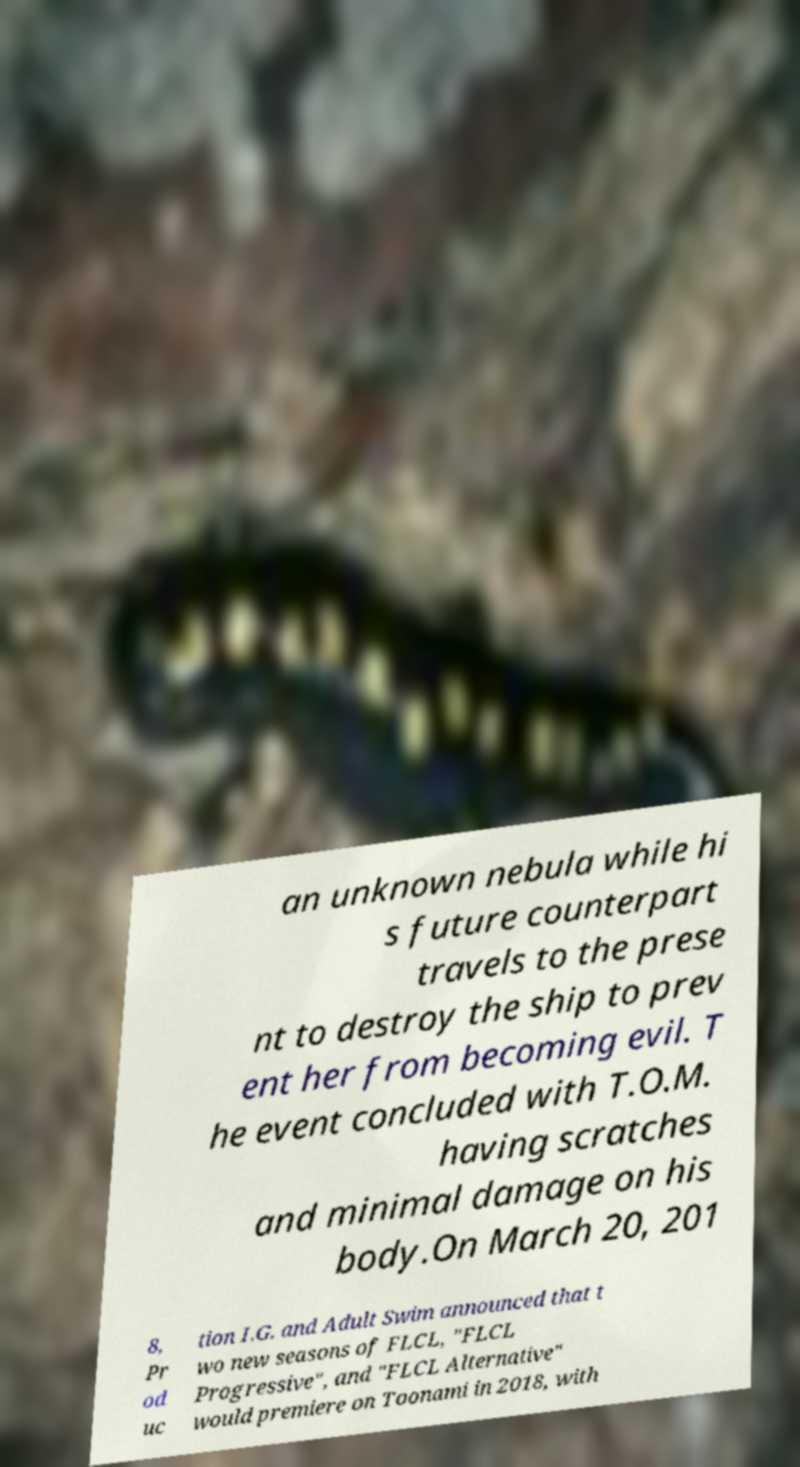For documentation purposes, I need the text within this image transcribed. Could you provide that? an unknown nebula while hi s future counterpart travels to the prese nt to destroy the ship to prev ent her from becoming evil. T he event concluded with T.O.M. having scratches and minimal damage on his body.On March 20, 201 8, Pr od uc tion I.G. and Adult Swim announced that t wo new seasons of FLCL, "FLCL Progressive", and "FLCL Alternative" would premiere on Toonami in 2018, with 